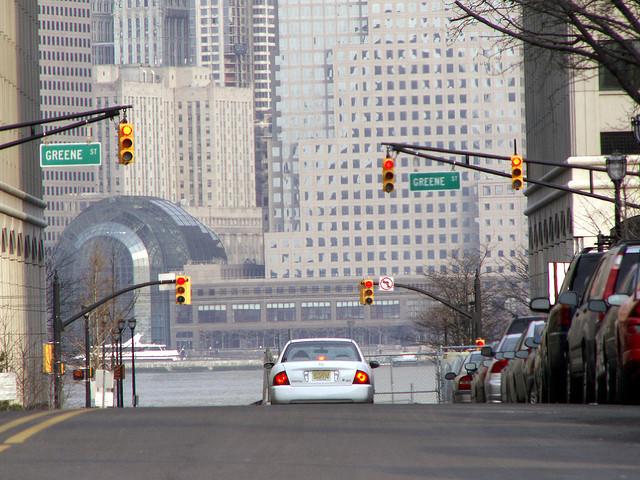What street is the car crossing?
Keep it brief. Greene. How many white cars are in operation?
Quick response, please. 1. What is the color of the car?
Concise answer only. White. 